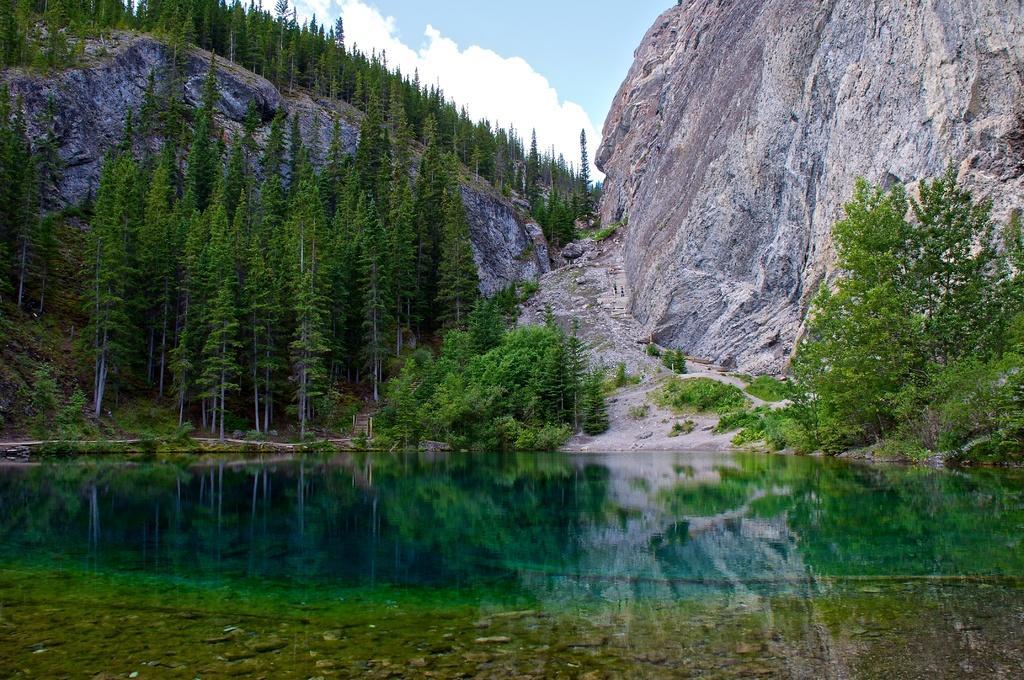Can you describe this image briefly? This picture is clicked outside. In the foreground we can see a water body. In the center we can see the trees and plants. In the background we can see the sky with the clouds and we can see the trees and the rocks. 